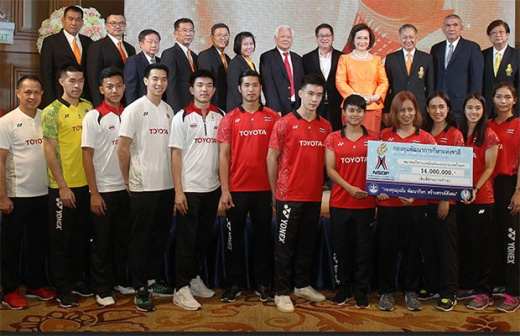Imagine a creative backstory for this event. Once every decade, the Grand Hall of Opulence hosts the legendary 'Champions and Benefactors Gala,' an event shrouded in secrecy and grandeur. Athletes who have surpassed records in their fields and contributed to their communities are invited, and benefactors like Toyota, who have supported sports development, present enormous ceremonial checks as part of their contributions to the future of sports. The climax of the evening is the unveiling of a 'Legacy Fund,' symbolized by a grand check, which promises to revolutionize sports facilities and youth training programs across the nation. The gala also serves as a meeting ground for sports and business elites to forge new alliances, ensuring the event's ongoing mystique and significance. How would this scene look if it were a painting titled 'The Generous Gesture'? In the painting 'The Generous Gesture,' the scene would be infused with rich, warm tones to highlight the grandeur of the room and the significance of the moment. The individuals in their colorful sports uniforms and formal attire would be depicted with meticulous detail, their expressions capturing a mix of pride and respect. The large check would be the focal point, glowing with an ethereal light symbolizing hope and future possibilities. The athletes in the front row would have a dynamic stance, reflecting their energy and dedication, while the dignitaries in the back row would exude calm authority. The chandelier in the background would sparkle softly, casting a gentle, dignified light over the proceedings, and the curtain would be rendered in deep, luxurious hues, framing the scene like a stage in a grand theatre. 